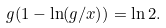Convert formula to latex. <formula><loc_0><loc_0><loc_500><loc_500>g ( 1 - \ln ( g / x ) ) = \ln 2 .</formula> 